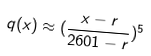Convert formula to latex. <formula><loc_0><loc_0><loc_500><loc_500>q ( x ) \approx ( \frac { x - r } { 2 6 0 1 - r } ) ^ { 5 }</formula> 